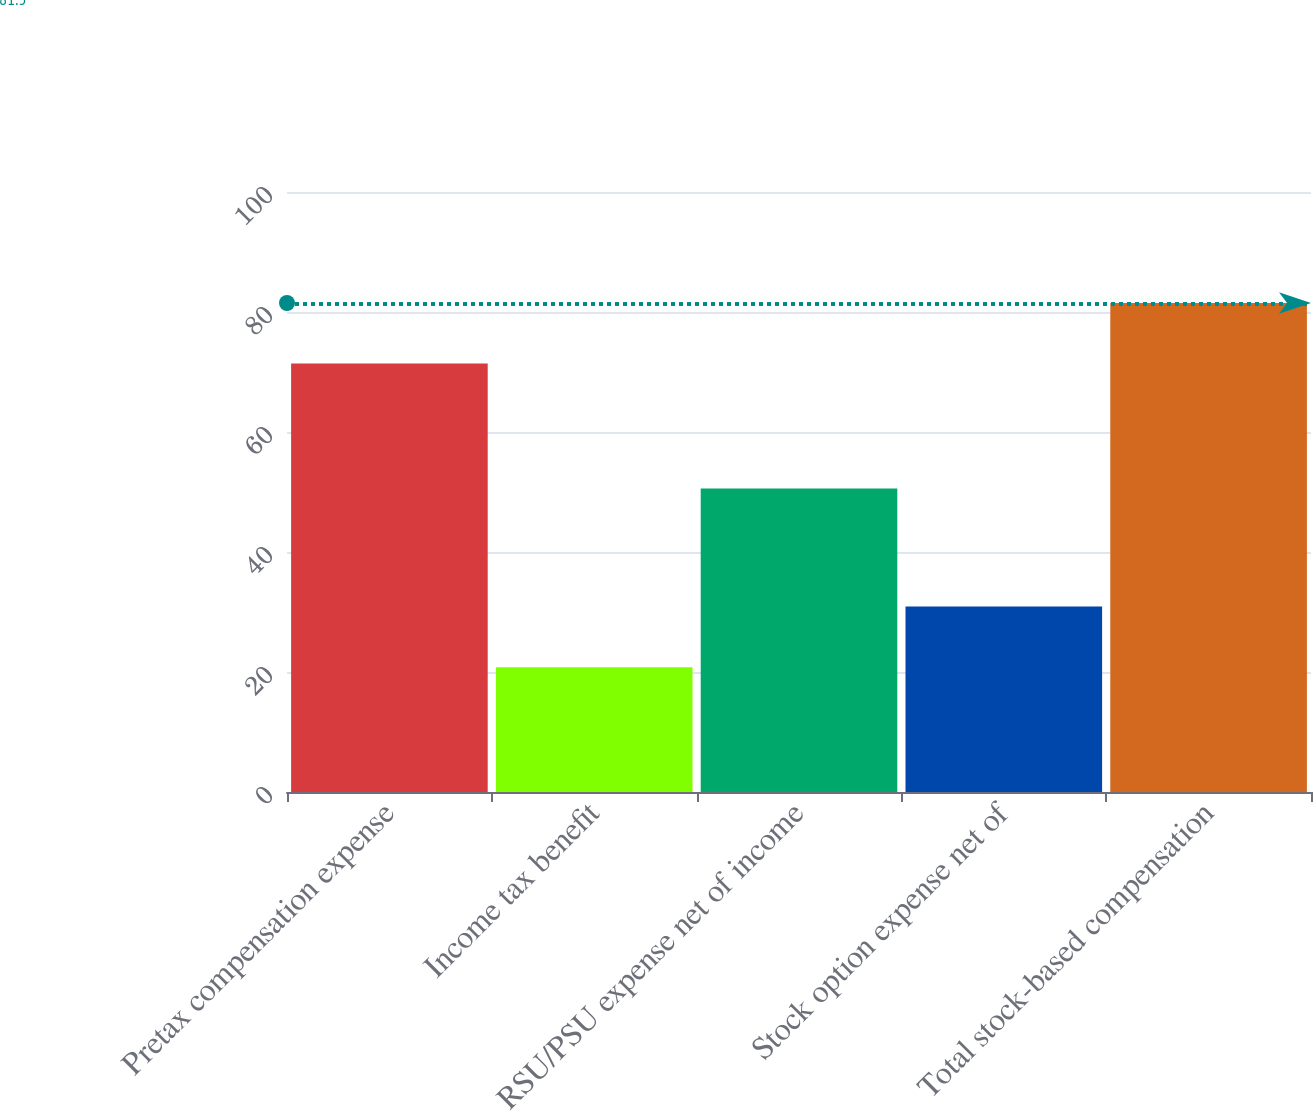Convert chart. <chart><loc_0><loc_0><loc_500><loc_500><bar_chart><fcel>Pretax compensation expense<fcel>Income tax benefit<fcel>RSU/PSU expense net of income<fcel>Stock option expense net of<fcel>Total stock-based compensation<nl><fcel>71.4<fcel>20.8<fcel>50.6<fcel>30.9<fcel>81.5<nl></chart> 